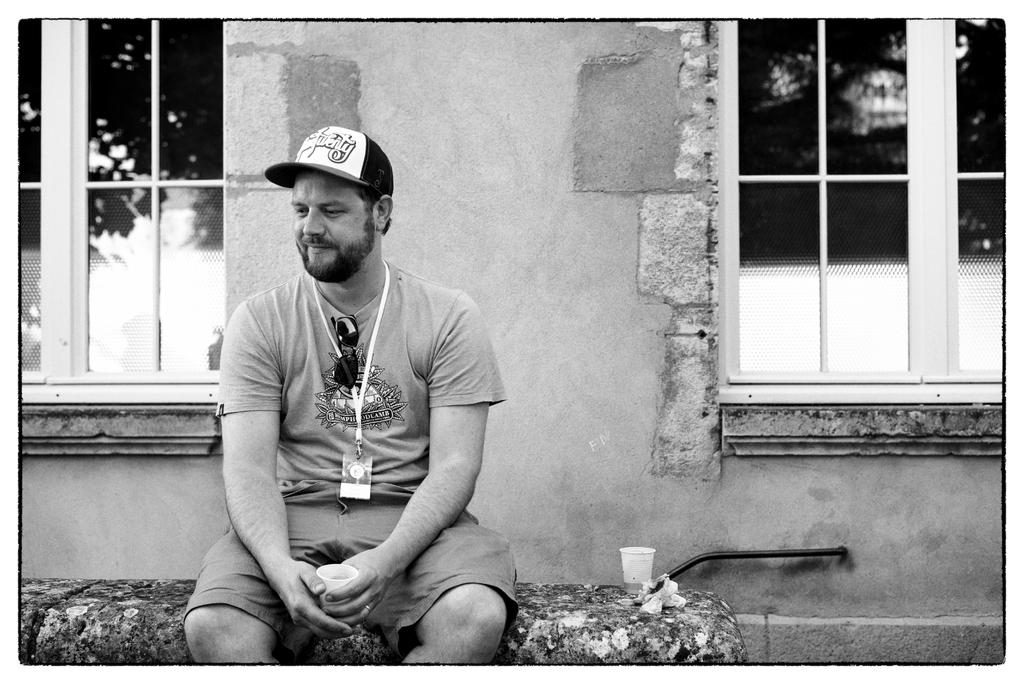What is the man in the image doing? The man is sitting in the image. What is the man holding in the image? The man is holding a cup in the image. What can be seen in the background of the image? There is a wall in the background of the image. What type of windows are present on both sides of the image? There are glass windows on both the right and left sides of the image. What is the man wearing on his head? The man is wearing a cap in the image. Can you see any stars in the image? There are no stars visible in the image. Is the man skating in the image? The man is sitting, not skating, in the image. 